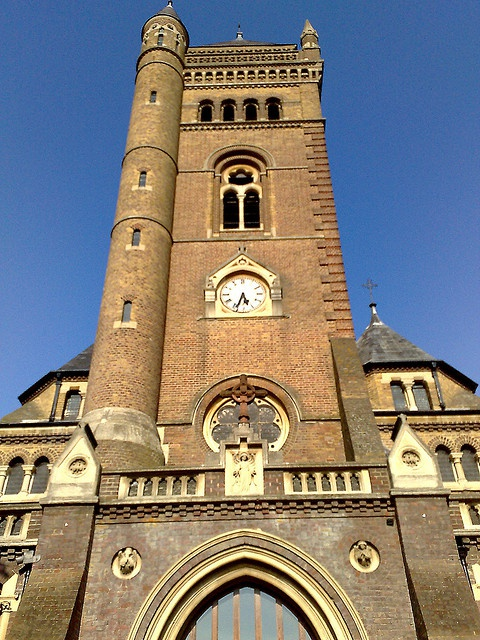Describe the objects in this image and their specific colors. I can see a clock in blue, ivory, and tan tones in this image. 